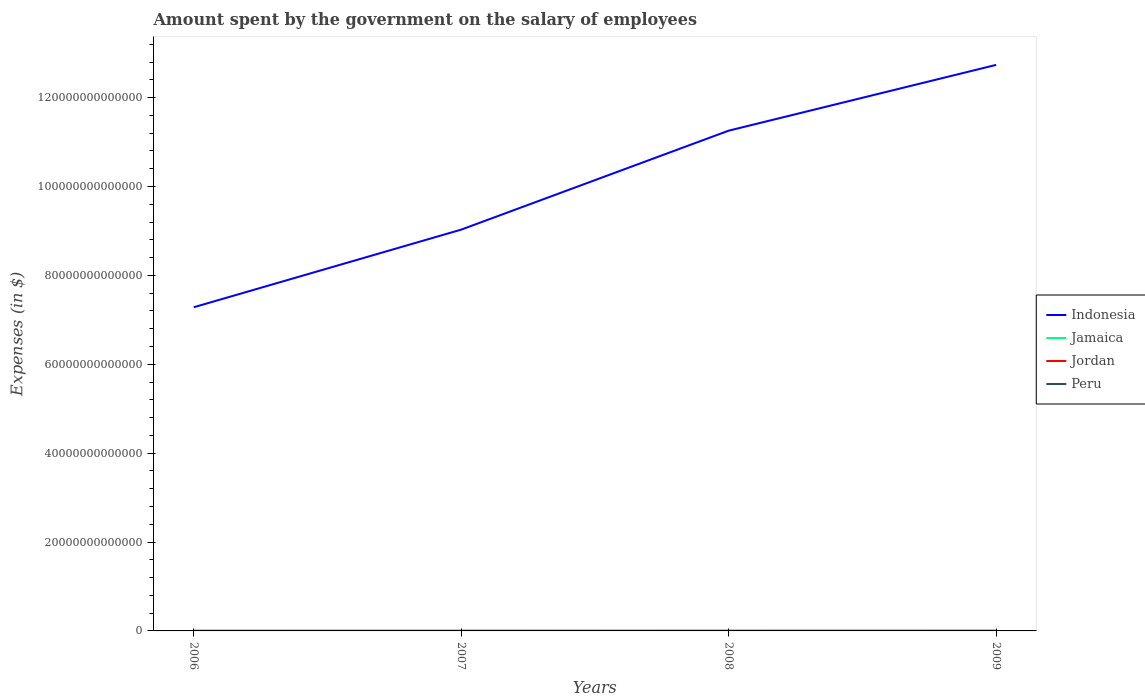How many different coloured lines are there?
Give a very brief answer. 4. Does the line corresponding to Indonesia intersect with the line corresponding to Jordan?
Offer a very short reply. No. Across all years, what is the maximum amount spent on the salary of employees by the government in Peru?
Your response must be concise. 9.74e+09. What is the total amount spent on the salary of employees by the government in Jordan in the graph?
Keep it short and to the point. -1.44e+08. What is the difference between the highest and the second highest amount spent on the salary of employees by the government in Peru?
Your answer should be compact. 2.42e+09. How many years are there in the graph?
Give a very brief answer. 4. What is the difference between two consecutive major ticks on the Y-axis?
Keep it short and to the point. 2.00e+13. Are the values on the major ticks of Y-axis written in scientific E-notation?
Ensure brevity in your answer.  No. What is the title of the graph?
Give a very brief answer. Amount spent by the government on the salary of employees. What is the label or title of the X-axis?
Keep it short and to the point. Years. What is the label or title of the Y-axis?
Your answer should be very brief. Expenses (in $). What is the Expenses (in $) in Indonesia in 2006?
Offer a terse response. 7.28e+13. What is the Expenses (in $) in Jamaica in 2006?
Your response must be concise. 4.24e+1. What is the Expenses (in $) of Jordan in 2006?
Provide a short and direct response. 1.38e+09. What is the Expenses (in $) of Peru in 2006?
Provide a succinct answer. 9.74e+09. What is the Expenses (in $) of Indonesia in 2007?
Your response must be concise. 9.03e+13. What is the Expenses (in $) in Jamaica in 2007?
Make the answer very short. 4.76e+1. What is the Expenses (in $) in Jordan in 2007?
Provide a succinct answer. 1.07e+09. What is the Expenses (in $) in Peru in 2007?
Provide a short and direct response. 1.00e+1. What is the Expenses (in $) in Indonesia in 2008?
Provide a succinct answer. 1.13e+14. What is the Expenses (in $) of Jamaica in 2008?
Provide a succinct answer. 5.89e+1. What is the Expenses (in $) in Jordan in 2008?
Keep it short and to the point. 2.39e+09. What is the Expenses (in $) in Peru in 2008?
Make the answer very short. 1.10e+1. What is the Expenses (in $) in Indonesia in 2009?
Your answer should be compact. 1.27e+14. What is the Expenses (in $) in Jamaica in 2009?
Offer a terse response. 6.50e+1. What is the Expenses (in $) in Jordan in 2009?
Your response must be concise. 2.53e+09. What is the Expenses (in $) in Peru in 2009?
Your answer should be very brief. 1.22e+1. Across all years, what is the maximum Expenses (in $) in Indonesia?
Provide a succinct answer. 1.27e+14. Across all years, what is the maximum Expenses (in $) in Jamaica?
Your response must be concise. 6.50e+1. Across all years, what is the maximum Expenses (in $) in Jordan?
Offer a terse response. 2.53e+09. Across all years, what is the maximum Expenses (in $) of Peru?
Your response must be concise. 1.22e+1. Across all years, what is the minimum Expenses (in $) in Indonesia?
Provide a succinct answer. 7.28e+13. Across all years, what is the minimum Expenses (in $) of Jamaica?
Ensure brevity in your answer.  4.24e+1. Across all years, what is the minimum Expenses (in $) in Jordan?
Offer a very short reply. 1.07e+09. Across all years, what is the minimum Expenses (in $) in Peru?
Make the answer very short. 9.74e+09. What is the total Expenses (in $) in Indonesia in the graph?
Make the answer very short. 4.03e+14. What is the total Expenses (in $) in Jamaica in the graph?
Offer a terse response. 2.14e+11. What is the total Expenses (in $) in Jordan in the graph?
Your response must be concise. 7.37e+09. What is the total Expenses (in $) of Peru in the graph?
Your answer should be very brief. 4.30e+1. What is the difference between the Expenses (in $) of Indonesia in 2006 and that in 2007?
Give a very brief answer. -1.75e+13. What is the difference between the Expenses (in $) in Jamaica in 2006 and that in 2007?
Ensure brevity in your answer.  -5.18e+09. What is the difference between the Expenses (in $) in Jordan in 2006 and that in 2007?
Offer a terse response. 3.15e+08. What is the difference between the Expenses (in $) in Peru in 2006 and that in 2007?
Offer a very short reply. -3.02e+08. What is the difference between the Expenses (in $) of Indonesia in 2006 and that in 2008?
Ensure brevity in your answer.  -3.97e+13. What is the difference between the Expenses (in $) in Jamaica in 2006 and that in 2008?
Your answer should be compact. -1.64e+1. What is the difference between the Expenses (in $) of Jordan in 2006 and that in 2008?
Make the answer very short. -1.01e+09. What is the difference between the Expenses (in $) of Peru in 2006 and that in 2008?
Ensure brevity in your answer.  -1.27e+09. What is the difference between the Expenses (in $) in Indonesia in 2006 and that in 2009?
Keep it short and to the point. -5.45e+13. What is the difference between the Expenses (in $) of Jamaica in 2006 and that in 2009?
Provide a short and direct response. -2.26e+1. What is the difference between the Expenses (in $) of Jordan in 2006 and that in 2009?
Provide a succinct answer. -1.15e+09. What is the difference between the Expenses (in $) in Peru in 2006 and that in 2009?
Your answer should be very brief. -2.42e+09. What is the difference between the Expenses (in $) of Indonesia in 2007 and that in 2008?
Offer a terse response. -2.23e+13. What is the difference between the Expenses (in $) of Jamaica in 2007 and that in 2008?
Your response must be concise. -1.13e+1. What is the difference between the Expenses (in $) in Jordan in 2007 and that in 2008?
Provide a succinct answer. -1.32e+09. What is the difference between the Expenses (in $) of Peru in 2007 and that in 2008?
Ensure brevity in your answer.  -9.68e+08. What is the difference between the Expenses (in $) in Indonesia in 2007 and that in 2009?
Ensure brevity in your answer.  -3.71e+13. What is the difference between the Expenses (in $) of Jamaica in 2007 and that in 2009?
Give a very brief answer. -1.74e+1. What is the difference between the Expenses (in $) of Jordan in 2007 and that in 2009?
Your response must be concise. -1.47e+09. What is the difference between the Expenses (in $) of Peru in 2007 and that in 2009?
Ensure brevity in your answer.  -2.11e+09. What is the difference between the Expenses (in $) in Indonesia in 2008 and that in 2009?
Keep it short and to the point. -1.48e+13. What is the difference between the Expenses (in $) of Jamaica in 2008 and that in 2009?
Make the answer very short. -6.14e+09. What is the difference between the Expenses (in $) of Jordan in 2008 and that in 2009?
Your answer should be very brief. -1.44e+08. What is the difference between the Expenses (in $) of Peru in 2008 and that in 2009?
Give a very brief answer. -1.15e+09. What is the difference between the Expenses (in $) in Indonesia in 2006 and the Expenses (in $) in Jamaica in 2007?
Your answer should be compact. 7.28e+13. What is the difference between the Expenses (in $) in Indonesia in 2006 and the Expenses (in $) in Jordan in 2007?
Offer a very short reply. 7.28e+13. What is the difference between the Expenses (in $) in Indonesia in 2006 and the Expenses (in $) in Peru in 2007?
Ensure brevity in your answer.  7.28e+13. What is the difference between the Expenses (in $) of Jamaica in 2006 and the Expenses (in $) of Jordan in 2007?
Provide a short and direct response. 4.14e+1. What is the difference between the Expenses (in $) in Jamaica in 2006 and the Expenses (in $) in Peru in 2007?
Keep it short and to the point. 3.24e+1. What is the difference between the Expenses (in $) of Jordan in 2006 and the Expenses (in $) of Peru in 2007?
Provide a short and direct response. -8.66e+09. What is the difference between the Expenses (in $) in Indonesia in 2006 and the Expenses (in $) in Jamaica in 2008?
Ensure brevity in your answer.  7.28e+13. What is the difference between the Expenses (in $) in Indonesia in 2006 and the Expenses (in $) in Jordan in 2008?
Provide a short and direct response. 7.28e+13. What is the difference between the Expenses (in $) of Indonesia in 2006 and the Expenses (in $) of Peru in 2008?
Ensure brevity in your answer.  7.28e+13. What is the difference between the Expenses (in $) of Jamaica in 2006 and the Expenses (in $) of Jordan in 2008?
Provide a short and direct response. 4.00e+1. What is the difference between the Expenses (in $) in Jamaica in 2006 and the Expenses (in $) in Peru in 2008?
Provide a succinct answer. 3.14e+1. What is the difference between the Expenses (in $) in Jordan in 2006 and the Expenses (in $) in Peru in 2008?
Ensure brevity in your answer.  -9.63e+09. What is the difference between the Expenses (in $) in Indonesia in 2006 and the Expenses (in $) in Jamaica in 2009?
Make the answer very short. 7.28e+13. What is the difference between the Expenses (in $) of Indonesia in 2006 and the Expenses (in $) of Jordan in 2009?
Offer a terse response. 7.28e+13. What is the difference between the Expenses (in $) of Indonesia in 2006 and the Expenses (in $) of Peru in 2009?
Ensure brevity in your answer.  7.28e+13. What is the difference between the Expenses (in $) in Jamaica in 2006 and the Expenses (in $) in Jordan in 2009?
Ensure brevity in your answer.  3.99e+1. What is the difference between the Expenses (in $) in Jamaica in 2006 and the Expenses (in $) in Peru in 2009?
Provide a short and direct response. 3.03e+1. What is the difference between the Expenses (in $) in Jordan in 2006 and the Expenses (in $) in Peru in 2009?
Your response must be concise. -1.08e+1. What is the difference between the Expenses (in $) in Indonesia in 2007 and the Expenses (in $) in Jamaica in 2008?
Offer a terse response. 9.02e+13. What is the difference between the Expenses (in $) in Indonesia in 2007 and the Expenses (in $) in Jordan in 2008?
Provide a succinct answer. 9.03e+13. What is the difference between the Expenses (in $) in Indonesia in 2007 and the Expenses (in $) in Peru in 2008?
Your answer should be very brief. 9.03e+13. What is the difference between the Expenses (in $) in Jamaica in 2007 and the Expenses (in $) in Jordan in 2008?
Your answer should be compact. 4.52e+1. What is the difference between the Expenses (in $) in Jamaica in 2007 and the Expenses (in $) in Peru in 2008?
Provide a succinct answer. 3.66e+1. What is the difference between the Expenses (in $) of Jordan in 2007 and the Expenses (in $) of Peru in 2008?
Provide a succinct answer. -9.95e+09. What is the difference between the Expenses (in $) in Indonesia in 2007 and the Expenses (in $) in Jamaica in 2009?
Ensure brevity in your answer.  9.02e+13. What is the difference between the Expenses (in $) in Indonesia in 2007 and the Expenses (in $) in Jordan in 2009?
Your answer should be compact. 9.03e+13. What is the difference between the Expenses (in $) of Indonesia in 2007 and the Expenses (in $) of Peru in 2009?
Make the answer very short. 9.03e+13. What is the difference between the Expenses (in $) in Jamaica in 2007 and the Expenses (in $) in Jordan in 2009?
Your answer should be very brief. 4.51e+1. What is the difference between the Expenses (in $) of Jamaica in 2007 and the Expenses (in $) of Peru in 2009?
Provide a succinct answer. 3.54e+1. What is the difference between the Expenses (in $) in Jordan in 2007 and the Expenses (in $) in Peru in 2009?
Your answer should be very brief. -1.11e+1. What is the difference between the Expenses (in $) in Indonesia in 2008 and the Expenses (in $) in Jamaica in 2009?
Offer a terse response. 1.13e+14. What is the difference between the Expenses (in $) in Indonesia in 2008 and the Expenses (in $) in Jordan in 2009?
Your answer should be very brief. 1.13e+14. What is the difference between the Expenses (in $) of Indonesia in 2008 and the Expenses (in $) of Peru in 2009?
Ensure brevity in your answer.  1.13e+14. What is the difference between the Expenses (in $) in Jamaica in 2008 and the Expenses (in $) in Jordan in 2009?
Give a very brief answer. 5.63e+1. What is the difference between the Expenses (in $) of Jamaica in 2008 and the Expenses (in $) of Peru in 2009?
Ensure brevity in your answer.  4.67e+1. What is the difference between the Expenses (in $) of Jordan in 2008 and the Expenses (in $) of Peru in 2009?
Your answer should be compact. -9.77e+09. What is the average Expenses (in $) in Indonesia per year?
Offer a terse response. 1.01e+14. What is the average Expenses (in $) of Jamaica per year?
Provide a succinct answer. 5.35e+1. What is the average Expenses (in $) of Jordan per year?
Keep it short and to the point. 1.84e+09. What is the average Expenses (in $) of Peru per year?
Offer a very short reply. 1.07e+1. In the year 2006, what is the difference between the Expenses (in $) of Indonesia and Expenses (in $) of Jamaica?
Your answer should be compact. 7.28e+13. In the year 2006, what is the difference between the Expenses (in $) of Indonesia and Expenses (in $) of Jordan?
Provide a short and direct response. 7.28e+13. In the year 2006, what is the difference between the Expenses (in $) in Indonesia and Expenses (in $) in Peru?
Provide a succinct answer. 7.28e+13. In the year 2006, what is the difference between the Expenses (in $) in Jamaica and Expenses (in $) in Jordan?
Your answer should be compact. 4.10e+1. In the year 2006, what is the difference between the Expenses (in $) of Jamaica and Expenses (in $) of Peru?
Give a very brief answer. 3.27e+1. In the year 2006, what is the difference between the Expenses (in $) in Jordan and Expenses (in $) in Peru?
Offer a very short reply. -8.36e+09. In the year 2007, what is the difference between the Expenses (in $) in Indonesia and Expenses (in $) in Jamaica?
Your answer should be compact. 9.03e+13. In the year 2007, what is the difference between the Expenses (in $) in Indonesia and Expenses (in $) in Jordan?
Ensure brevity in your answer.  9.03e+13. In the year 2007, what is the difference between the Expenses (in $) in Indonesia and Expenses (in $) in Peru?
Offer a terse response. 9.03e+13. In the year 2007, what is the difference between the Expenses (in $) in Jamaica and Expenses (in $) in Jordan?
Your answer should be very brief. 4.65e+1. In the year 2007, what is the difference between the Expenses (in $) of Jamaica and Expenses (in $) of Peru?
Your answer should be very brief. 3.76e+1. In the year 2007, what is the difference between the Expenses (in $) in Jordan and Expenses (in $) in Peru?
Offer a very short reply. -8.98e+09. In the year 2008, what is the difference between the Expenses (in $) in Indonesia and Expenses (in $) in Jamaica?
Provide a short and direct response. 1.13e+14. In the year 2008, what is the difference between the Expenses (in $) of Indonesia and Expenses (in $) of Jordan?
Provide a succinct answer. 1.13e+14. In the year 2008, what is the difference between the Expenses (in $) in Indonesia and Expenses (in $) in Peru?
Your answer should be compact. 1.13e+14. In the year 2008, what is the difference between the Expenses (in $) in Jamaica and Expenses (in $) in Jordan?
Provide a succinct answer. 5.65e+1. In the year 2008, what is the difference between the Expenses (in $) in Jamaica and Expenses (in $) in Peru?
Offer a terse response. 4.79e+1. In the year 2008, what is the difference between the Expenses (in $) in Jordan and Expenses (in $) in Peru?
Your answer should be very brief. -8.63e+09. In the year 2009, what is the difference between the Expenses (in $) in Indonesia and Expenses (in $) in Jamaica?
Make the answer very short. 1.27e+14. In the year 2009, what is the difference between the Expenses (in $) in Indonesia and Expenses (in $) in Jordan?
Provide a succinct answer. 1.27e+14. In the year 2009, what is the difference between the Expenses (in $) in Indonesia and Expenses (in $) in Peru?
Your answer should be compact. 1.27e+14. In the year 2009, what is the difference between the Expenses (in $) in Jamaica and Expenses (in $) in Jordan?
Make the answer very short. 6.25e+1. In the year 2009, what is the difference between the Expenses (in $) of Jamaica and Expenses (in $) of Peru?
Ensure brevity in your answer.  5.29e+1. In the year 2009, what is the difference between the Expenses (in $) of Jordan and Expenses (in $) of Peru?
Your answer should be very brief. -9.63e+09. What is the ratio of the Expenses (in $) of Indonesia in 2006 to that in 2007?
Give a very brief answer. 0.81. What is the ratio of the Expenses (in $) of Jamaica in 2006 to that in 2007?
Offer a very short reply. 0.89. What is the ratio of the Expenses (in $) in Jordan in 2006 to that in 2007?
Ensure brevity in your answer.  1.3. What is the ratio of the Expenses (in $) in Peru in 2006 to that in 2007?
Your answer should be very brief. 0.97. What is the ratio of the Expenses (in $) of Indonesia in 2006 to that in 2008?
Provide a short and direct response. 0.65. What is the ratio of the Expenses (in $) of Jamaica in 2006 to that in 2008?
Keep it short and to the point. 0.72. What is the ratio of the Expenses (in $) of Jordan in 2006 to that in 2008?
Provide a short and direct response. 0.58. What is the ratio of the Expenses (in $) of Peru in 2006 to that in 2008?
Your answer should be very brief. 0.88. What is the ratio of the Expenses (in $) of Indonesia in 2006 to that in 2009?
Offer a terse response. 0.57. What is the ratio of the Expenses (in $) in Jamaica in 2006 to that in 2009?
Keep it short and to the point. 0.65. What is the ratio of the Expenses (in $) of Jordan in 2006 to that in 2009?
Your answer should be very brief. 0.55. What is the ratio of the Expenses (in $) in Peru in 2006 to that in 2009?
Provide a short and direct response. 0.8. What is the ratio of the Expenses (in $) of Indonesia in 2007 to that in 2008?
Provide a short and direct response. 0.8. What is the ratio of the Expenses (in $) in Jamaica in 2007 to that in 2008?
Give a very brief answer. 0.81. What is the ratio of the Expenses (in $) of Jordan in 2007 to that in 2008?
Give a very brief answer. 0.45. What is the ratio of the Expenses (in $) of Peru in 2007 to that in 2008?
Keep it short and to the point. 0.91. What is the ratio of the Expenses (in $) in Indonesia in 2007 to that in 2009?
Offer a very short reply. 0.71. What is the ratio of the Expenses (in $) of Jamaica in 2007 to that in 2009?
Offer a terse response. 0.73. What is the ratio of the Expenses (in $) of Jordan in 2007 to that in 2009?
Your answer should be very brief. 0.42. What is the ratio of the Expenses (in $) in Peru in 2007 to that in 2009?
Keep it short and to the point. 0.83. What is the ratio of the Expenses (in $) in Indonesia in 2008 to that in 2009?
Your response must be concise. 0.88. What is the ratio of the Expenses (in $) in Jamaica in 2008 to that in 2009?
Offer a terse response. 0.91. What is the ratio of the Expenses (in $) of Jordan in 2008 to that in 2009?
Your answer should be very brief. 0.94. What is the ratio of the Expenses (in $) in Peru in 2008 to that in 2009?
Give a very brief answer. 0.91. What is the difference between the highest and the second highest Expenses (in $) in Indonesia?
Offer a very short reply. 1.48e+13. What is the difference between the highest and the second highest Expenses (in $) in Jamaica?
Make the answer very short. 6.14e+09. What is the difference between the highest and the second highest Expenses (in $) of Jordan?
Keep it short and to the point. 1.44e+08. What is the difference between the highest and the second highest Expenses (in $) in Peru?
Ensure brevity in your answer.  1.15e+09. What is the difference between the highest and the lowest Expenses (in $) of Indonesia?
Offer a terse response. 5.45e+13. What is the difference between the highest and the lowest Expenses (in $) in Jamaica?
Your answer should be compact. 2.26e+1. What is the difference between the highest and the lowest Expenses (in $) of Jordan?
Offer a very short reply. 1.47e+09. What is the difference between the highest and the lowest Expenses (in $) in Peru?
Offer a terse response. 2.42e+09. 